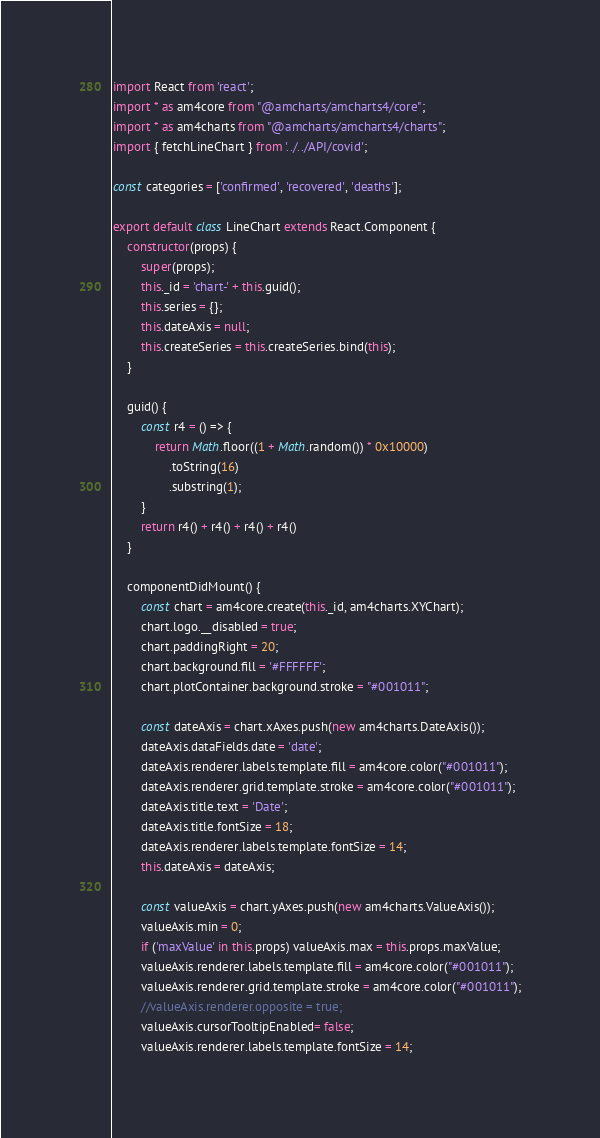Convert code to text. <code><loc_0><loc_0><loc_500><loc_500><_JavaScript_>import React from 'react';
import * as am4core from "@amcharts/amcharts4/core";
import * as am4charts from "@amcharts/amcharts4/charts";
import { fetchLineChart } from '../../API/covid';

const categories = ['confirmed', 'recovered', 'deaths'];

export default class LineChart extends React.Component {
    constructor(props) {
        super(props);
        this._id = 'chart-' + this.guid();
        this.series = {};
        this.dateAxis = null;
        this.createSeries = this.createSeries.bind(this);
    }

    guid() {
        const r4 = () => {
            return Math.floor((1 + Math.random()) * 0x10000)
                .toString(16)
                .substring(1);
        }
        return r4() + r4() + r4() + r4()
    }

    componentDidMount() {
        const chart = am4core.create(this._id, am4charts.XYChart);
        chart.logo.__disabled = true;
        chart.paddingRight = 20;
        chart.background.fill = '#FFFFFF';
        chart.plotContainer.background.stroke = "#001011";

        const dateAxis = chart.xAxes.push(new am4charts.DateAxis());
        dateAxis.dataFields.date = 'date';
        dateAxis.renderer.labels.template.fill = am4core.color("#001011");
        dateAxis.renderer.grid.template.stroke = am4core.color("#001011");
        dateAxis.title.text = 'Date';
        dateAxis.title.fontSize = 18;
        dateAxis.renderer.labels.template.fontSize = 14;
        this.dateAxis = dateAxis;

        const valueAxis = chart.yAxes.push(new am4charts.ValueAxis());
        valueAxis.min = 0;
        if ('maxValue' in this.props) valueAxis.max = this.props.maxValue; 
        valueAxis.renderer.labels.template.fill = am4core.color("#001011");
        valueAxis.renderer.grid.template.stroke = am4core.color("#001011");
        //valueAxis.renderer.opposite = true; 
        valueAxis.cursorTooltipEnabled= false; 
        valueAxis.renderer.labels.template.fontSize = 14;</code> 